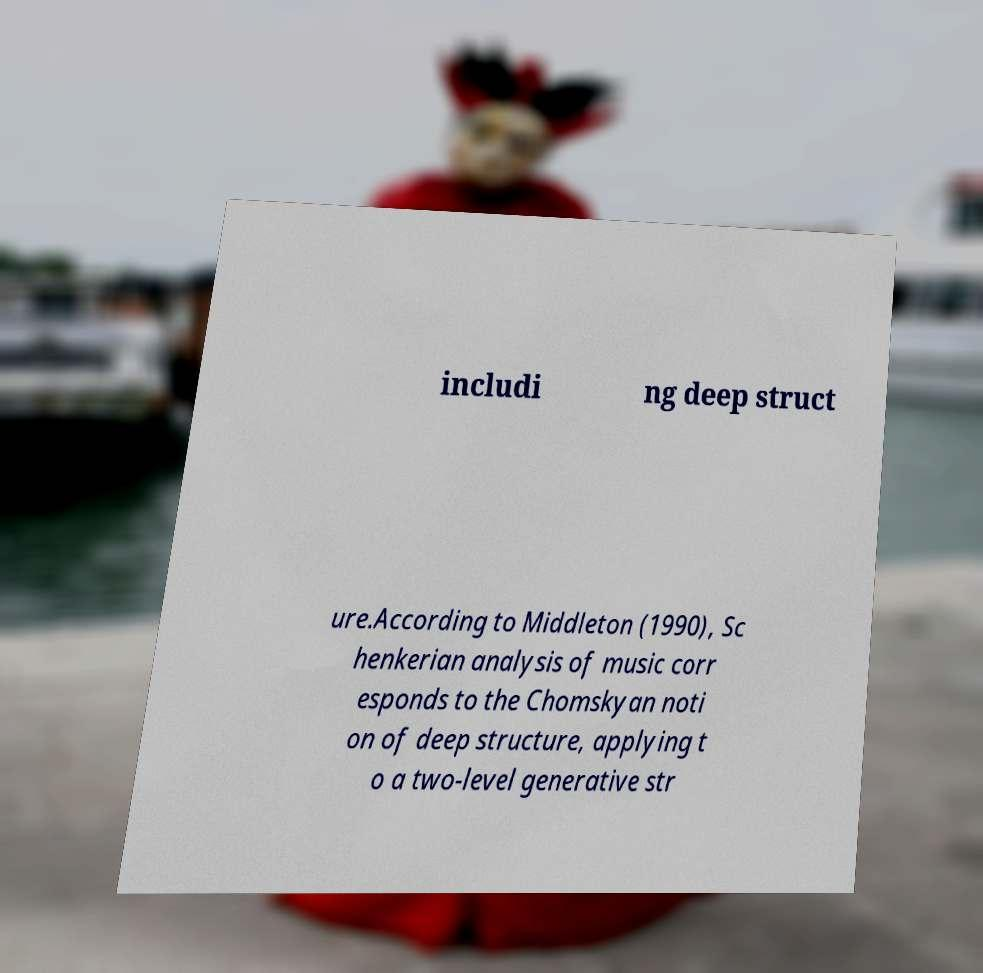Could you extract and type out the text from this image? includi ng deep struct ure.According to Middleton (1990), Sc henkerian analysis of music corr esponds to the Chomskyan noti on of deep structure, applying t o a two-level generative str 